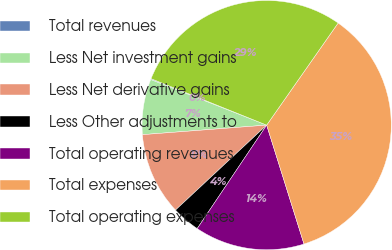<chart> <loc_0><loc_0><loc_500><loc_500><pie_chart><fcel>Total revenues<fcel>Less Net investment gains<fcel>Less Net derivative gains<fcel>Less Other adjustments to<fcel>Total operating revenues<fcel>Total expenses<fcel>Total operating expenses<nl><fcel>0.12%<fcel>7.18%<fcel>10.72%<fcel>3.65%<fcel>14.25%<fcel>35.44%<fcel>28.64%<nl></chart> 